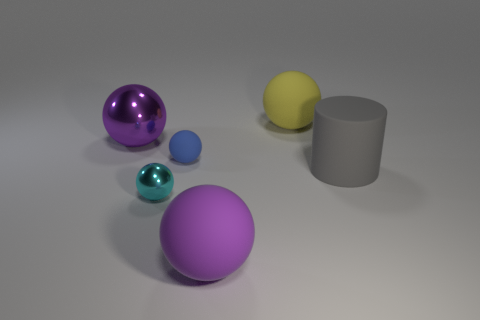What is the shape of the large thing that is the same color as the large shiny sphere?
Your answer should be very brief. Sphere. The small metal ball is what color?
Keep it short and to the point. Cyan. Are there any tiny matte spheres of the same color as the small metal object?
Your answer should be very brief. No. How many rubber things are behind the shiny ball in front of the large purple thing that is on the left side of the small shiny ball?
Provide a succinct answer. 3. There is another object that is the same color as the big metallic object; what size is it?
Ensure brevity in your answer.  Large. Are there any big yellow matte spheres in front of the gray cylinder?
Make the answer very short. No. The large purple rubber thing is what shape?
Your answer should be compact. Sphere. What is the shape of the purple thing that is on the right side of the big thing that is on the left side of the shiny object in front of the small blue rubber sphere?
Your answer should be very brief. Sphere. What number of other things are the same shape as the small blue matte object?
Give a very brief answer. 4. What is the material of the cyan thing to the right of the large purple sphere to the left of the big purple rubber ball?
Your response must be concise. Metal. 